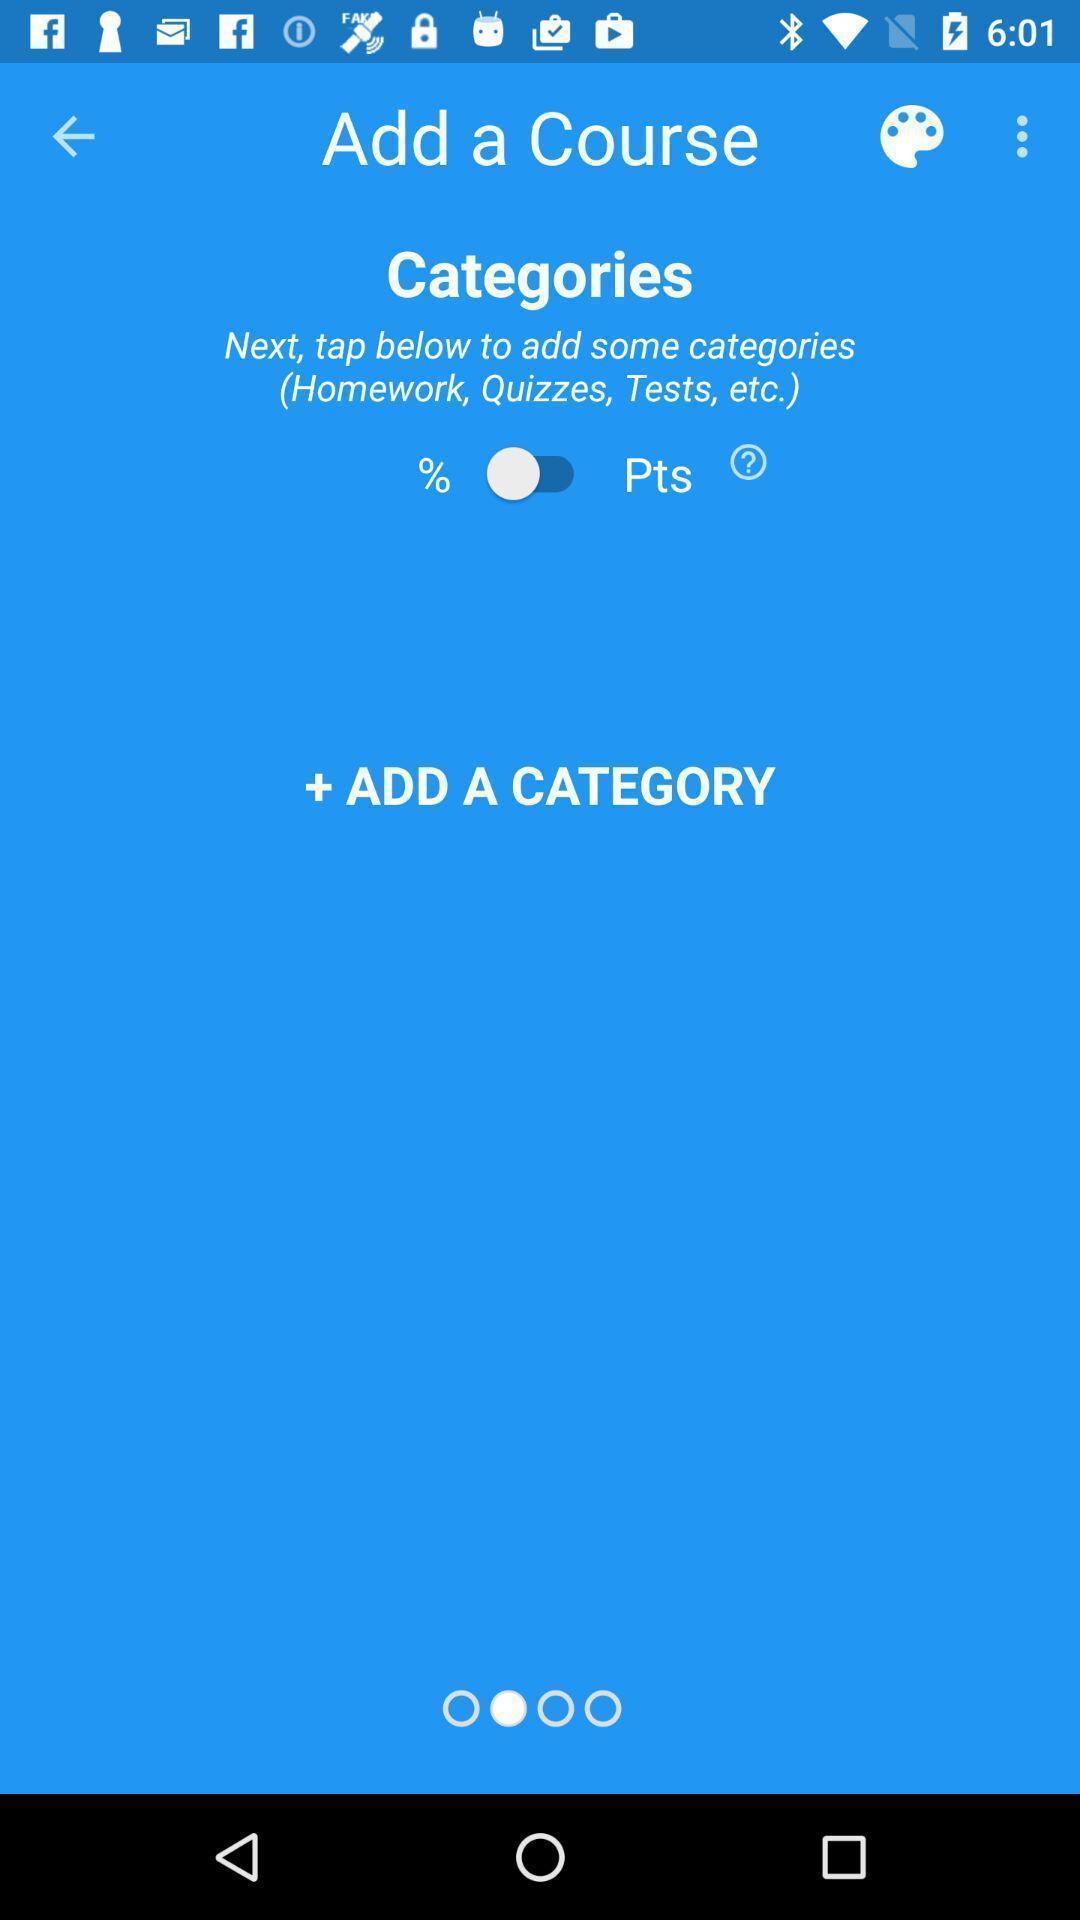Explain what's happening in this screen capture. Screen displaying the instruction to add a course. 